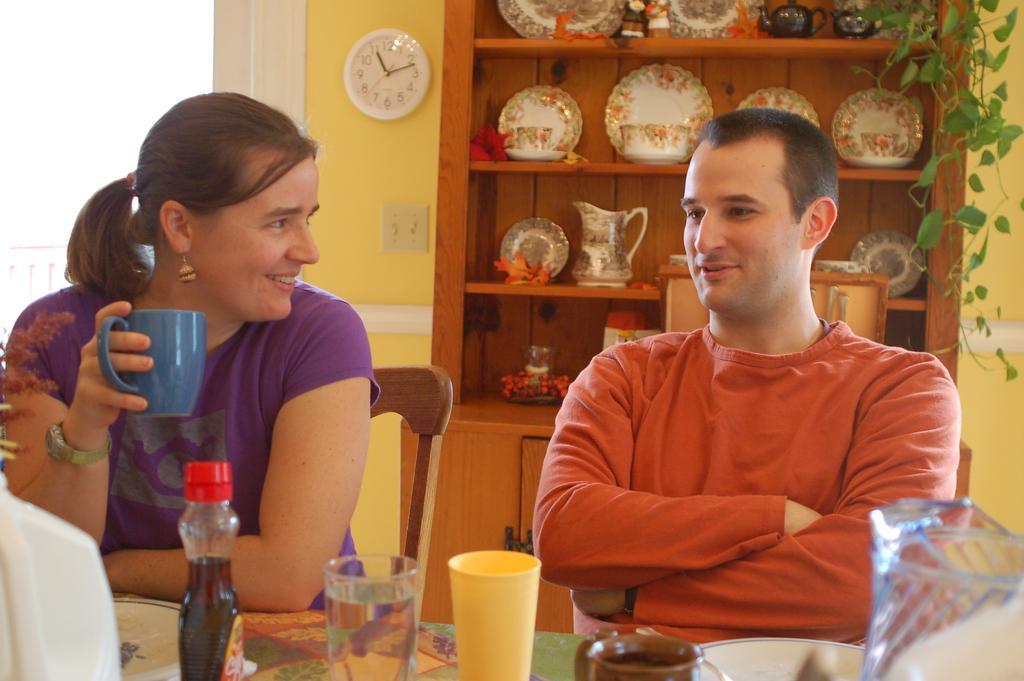Could you give a brief overview of what you see in this image? In this image there is a woman sitting on a chair by holding on a cup in her hand, having a smile on her face, beside the woman there is a man seated in a chair with a smile on his face, in front of them on the table there is a glass, cup, a bottle of sauce, plate and a glass jar, behind them on the cupboard there are a few plates and glasses, beside the cupboard there is a wall clock. 